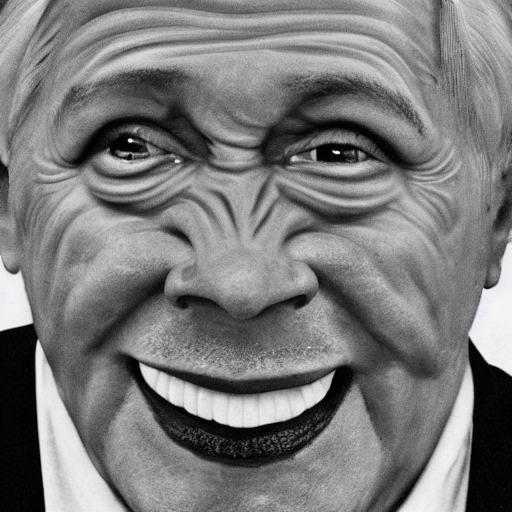Why is the lighting slightly weak? The response provided does not give an accurate or detailed explanation since there is no information about the lighting conditions or camera settings in the image. A more thorough answer would require analyzing the specific visual aspects of the image to determine any indications of weak lighting, such as visible shadows or a dim environment, which are not mentioned or discernible from this particular photograph. 